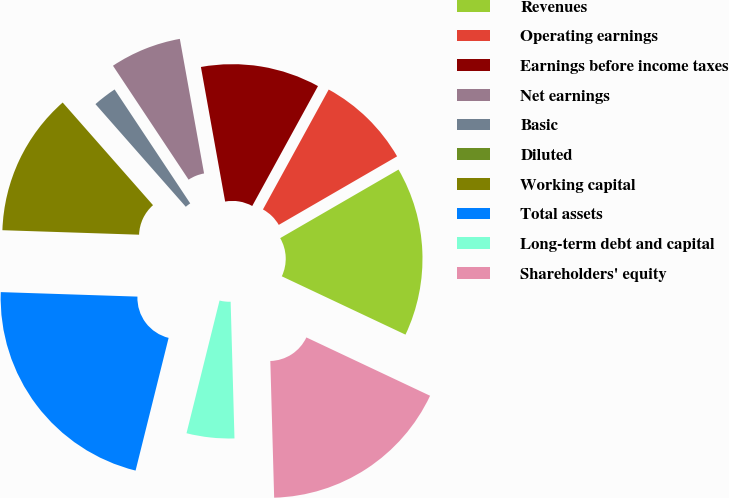Convert chart. <chart><loc_0><loc_0><loc_500><loc_500><pie_chart><fcel>Revenues<fcel>Operating earnings<fcel>Earnings before income taxes<fcel>Net earnings<fcel>Basic<fcel>Diluted<fcel>Working capital<fcel>Total assets<fcel>Long-term debt and capital<fcel>Shareholders' equity<nl><fcel>15.37%<fcel>8.66%<fcel>10.82%<fcel>6.49%<fcel>2.16%<fcel>0.0%<fcel>12.99%<fcel>21.64%<fcel>4.33%<fcel>17.54%<nl></chart> 